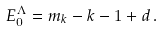<formula> <loc_0><loc_0><loc_500><loc_500>E _ { 0 } ^ { \Lambda } = m _ { k } - k - 1 + d \, .</formula> 